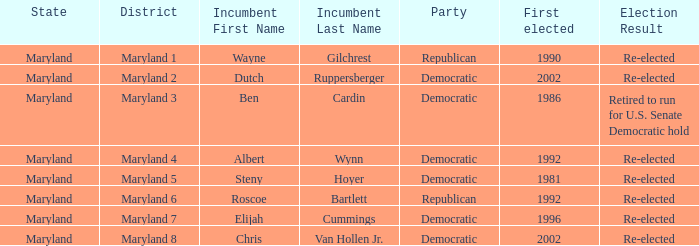Parse the full table. {'header': ['State', 'District', 'Incumbent First Name', 'Incumbent Last Name', 'Party', 'First elected', 'Election Result'], 'rows': [['Maryland', 'Maryland 1', 'Wayne', 'Gilchrest', 'Republican', '1990', 'Re-elected'], ['Maryland', 'Maryland 2', 'Dutch', 'Ruppersberger', 'Democratic', '2002', 'Re-elected'], ['Maryland', 'Maryland 3', 'Ben', 'Cardin', 'Democratic', '1986', 'Retired to run for U.S. Senate Democratic hold'], ['Maryland', 'Maryland 4', 'Albert', 'Wynn', 'Democratic', '1992', 'Re-elected'], ['Maryland', 'Maryland 5', 'Steny', 'Hoyer', 'Democratic', '1981', 'Re-elected'], ['Maryland', 'Maryland 6', 'Roscoe', 'Bartlett', 'Republican', '1992', 'Re-elected'], ['Maryland', 'Maryland 7', 'Elijah', 'Cummings', 'Democratic', '1996', 'Re-elected'], ['Maryland', 'Maryland 8', 'Chris', 'Van Hollen Jr.', 'Democratic', '2002', 'Re-elected']]} What is the party of the maryland 6 district? Republican. 